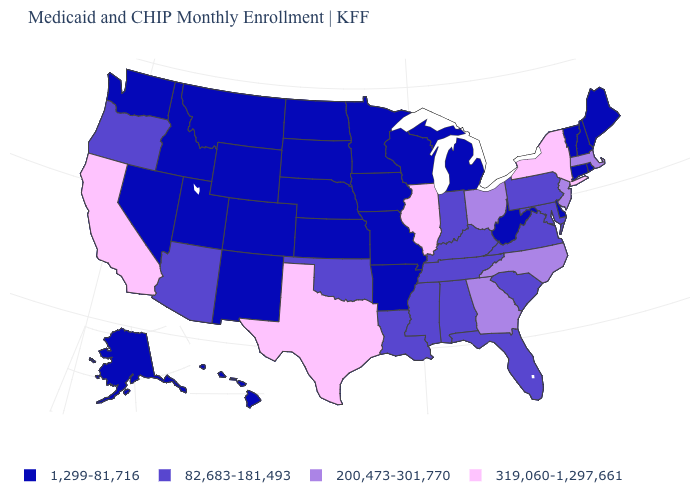Name the states that have a value in the range 82,683-181,493?
Be succinct. Alabama, Arizona, Florida, Indiana, Kentucky, Louisiana, Maryland, Mississippi, Oklahoma, Oregon, Pennsylvania, South Carolina, Tennessee, Virginia. Name the states that have a value in the range 1,299-81,716?
Answer briefly. Alaska, Arkansas, Colorado, Connecticut, Delaware, Hawaii, Idaho, Iowa, Kansas, Maine, Michigan, Minnesota, Missouri, Montana, Nebraska, Nevada, New Hampshire, New Mexico, North Dakota, Rhode Island, South Dakota, Utah, Vermont, Washington, West Virginia, Wisconsin, Wyoming. What is the value of North Carolina?
Keep it brief. 200,473-301,770. Name the states that have a value in the range 1,299-81,716?
Concise answer only. Alaska, Arkansas, Colorado, Connecticut, Delaware, Hawaii, Idaho, Iowa, Kansas, Maine, Michigan, Minnesota, Missouri, Montana, Nebraska, Nevada, New Hampshire, New Mexico, North Dakota, Rhode Island, South Dakota, Utah, Vermont, Washington, West Virginia, Wisconsin, Wyoming. What is the value of Maryland?
Concise answer only. 82,683-181,493. Which states have the lowest value in the South?
Short answer required. Arkansas, Delaware, West Virginia. Name the states that have a value in the range 82,683-181,493?
Concise answer only. Alabama, Arizona, Florida, Indiana, Kentucky, Louisiana, Maryland, Mississippi, Oklahoma, Oregon, Pennsylvania, South Carolina, Tennessee, Virginia. Does Connecticut have the highest value in the USA?
Short answer required. No. What is the highest value in the South ?
Give a very brief answer. 319,060-1,297,661. What is the highest value in the South ?
Answer briefly. 319,060-1,297,661. Name the states that have a value in the range 82,683-181,493?
Be succinct. Alabama, Arizona, Florida, Indiana, Kentucky, Louisiana, Maryland, Mississippi, Oklahoma, Oregon, Pennsylvania, South Carolina, Tennessee, Virginia. Name the states that have a value in the range 82,683-181,493?
Write a very short answer. Alabama, Arizona, Florida, Indiana, Kentucky, Louisiana, Maryland, Mississippi, Oklahoma, Oregon, Pennsylvania, South Carolina, Tennessee, Virginia. What is the lowest value in the USA?
Be succinct. 1,299-81,716. What is the value of Delaware?
Short answer required. 1,299-81,716. 